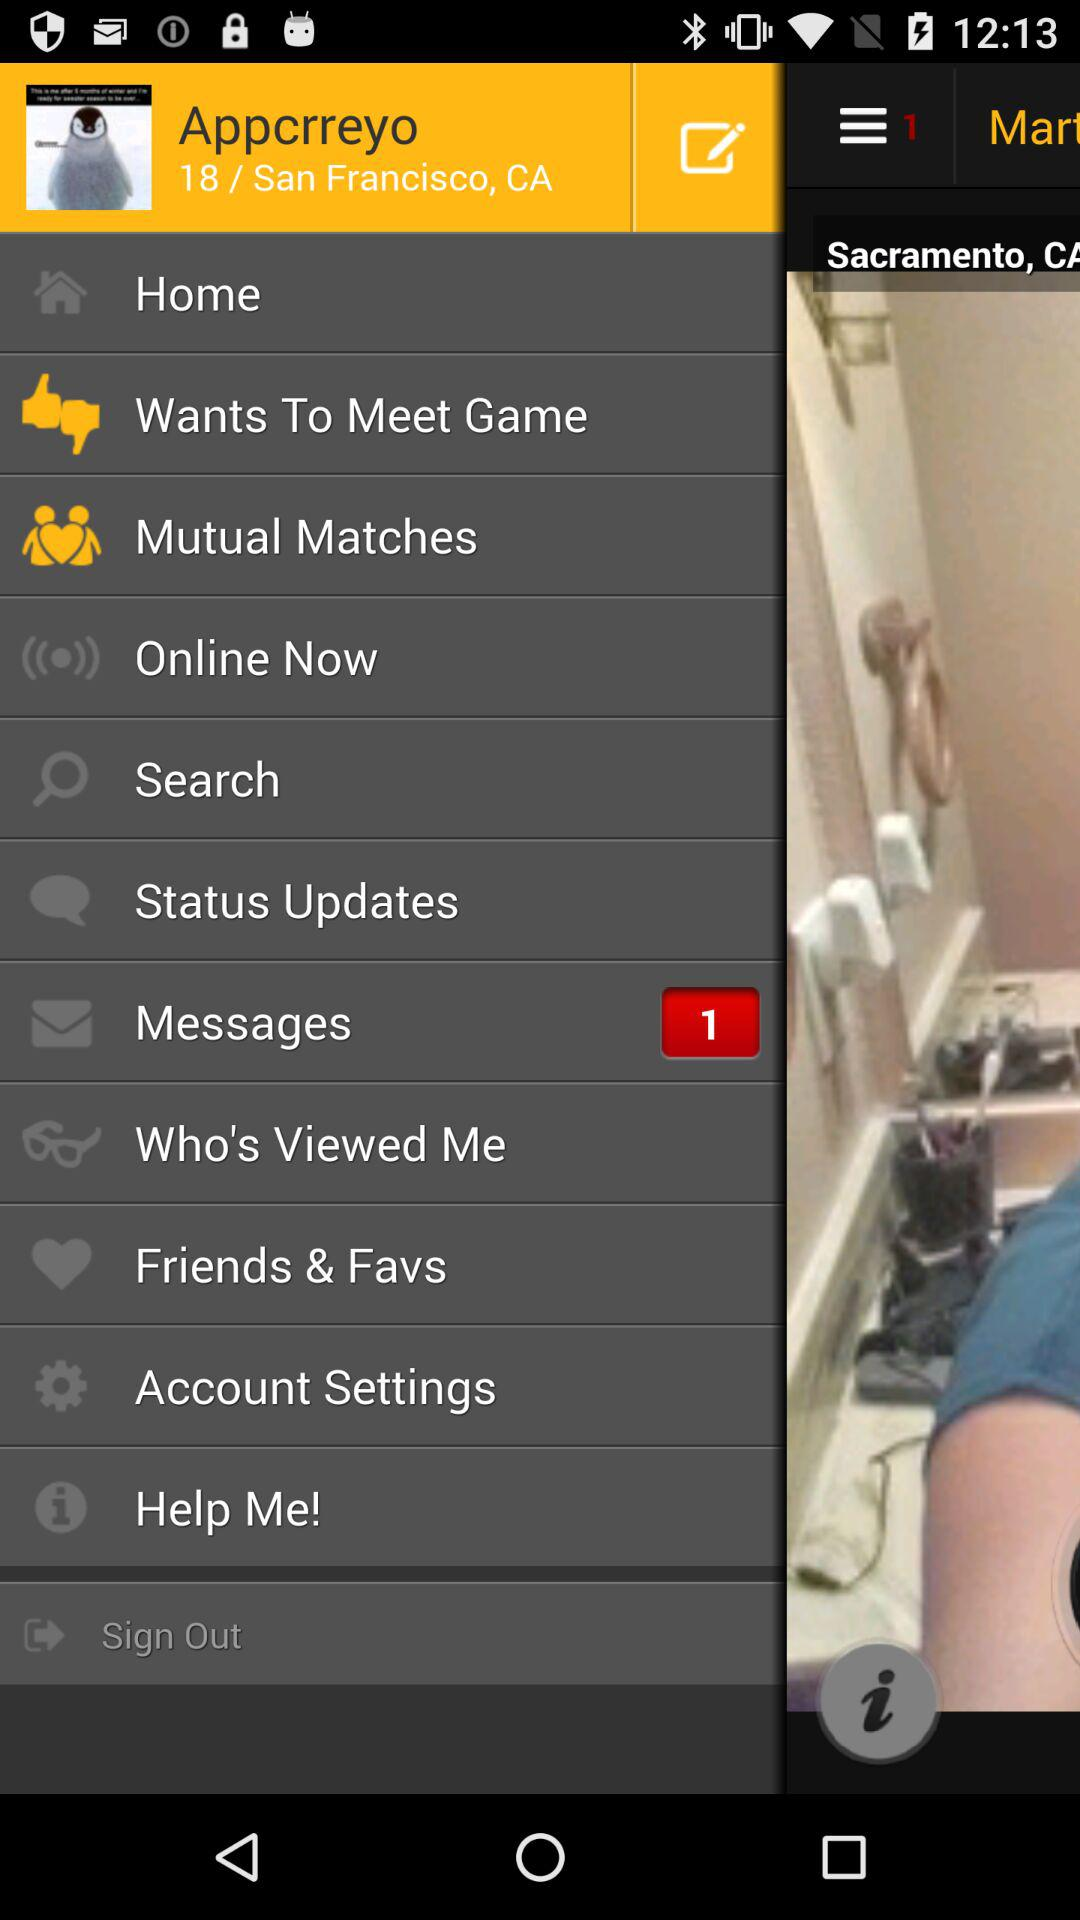What is the username? The username is "Appcrreyo". 